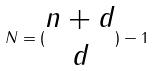Convert formula to latex. <formula><loc_0><loc_0><loc_500><loc_500>N = ( \begin{matrix} n + d \\ d \end{matrix} ) - 1</formula> 